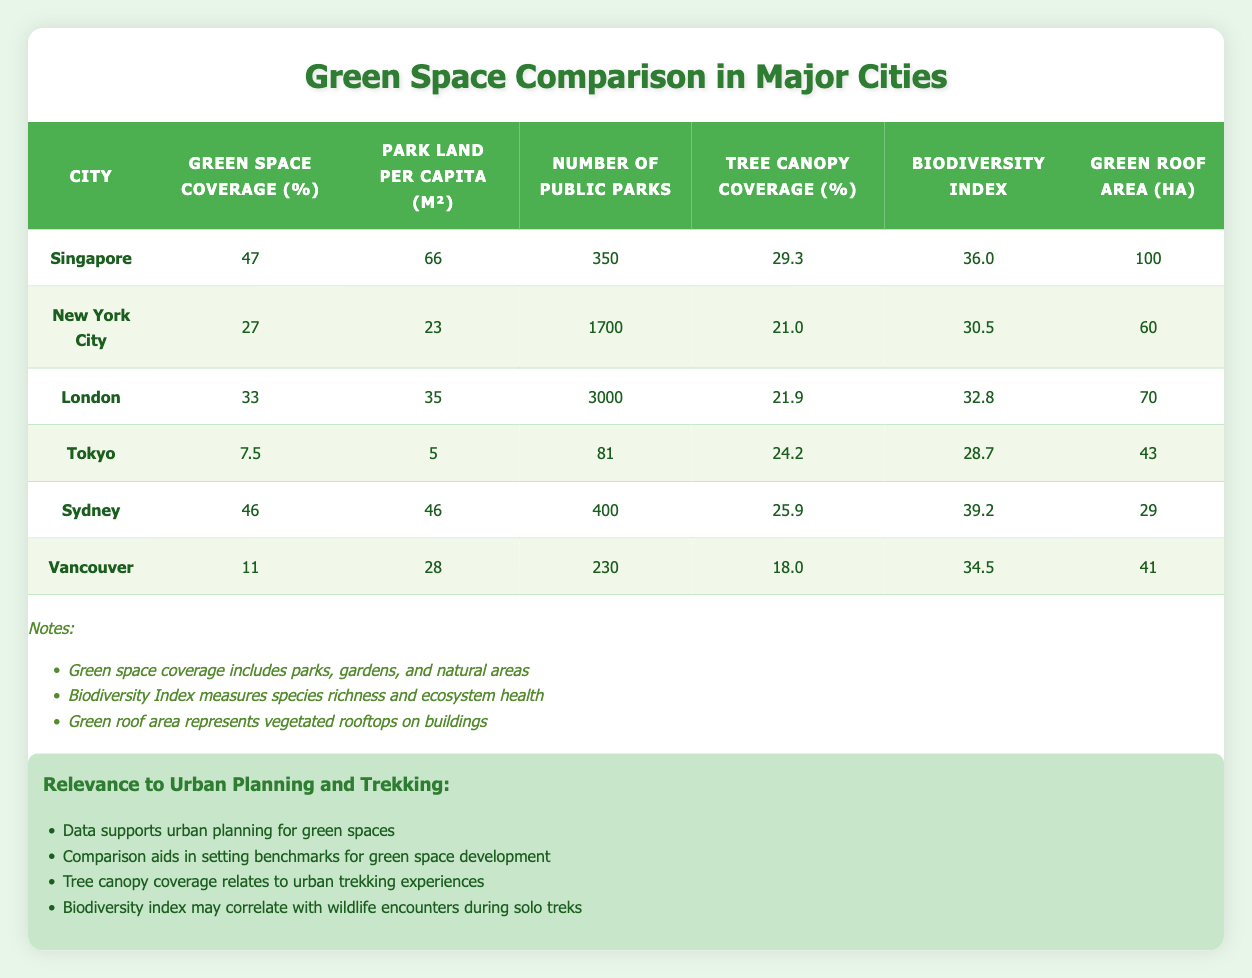What city has the highest green space coverage? By examining the "Green Space Coverage (%)" column, we see that Singapore has the highest value of 47%.
Answer: Singapore Which city has the most public parks? The "Number of Public Parks" column indicates that London has the highest count with 3000 public parks.
Answer: London What is the average park land per capita for the cities listed? To find the average, we sum the park land per capita values (66 + 23 + 35 + 5 + 46 + 28 = 203) and divide by the number of cities (203/6 = 33.83).
Answer: 33.83 m² Is the tree canopy coverage in Tokyo higher than that of New York City? Looking at the "Tree Canopy Coverage (%)" column, Tokyo has 24.2% while New York City has only 21.0%, so yes, Tokyo's coverage is higher.
Answer: Yes Which city has the lowest biodiversity index? The "Biodiversity Index" column shows that Tokyo has the lowest score of 28.7, indicating the least biodiversity among the cities.
Answer: Tokyo How much more green space coverage does Singapore have compared to Tokyo? We subtract Tokyo's green space coverage of 7.5% from Singapore's 47% (47 - 7.5 = 39.5), so Singapore has 39.5% more green space coverage.
Answer: 39.5% Is the tree canopy coverage in Sydney greater than the biodiversity index for New York City? Sydney has a tree canopy coverage of 25.9% while New York City has a biodiversity index of 30.5. Since 25.9% is not greater than 30.5, the answer is no.
Answer: No What is the total green roof area of all cities combined? Adding the green roof areas (100 + 60 + 70 + 43 + 29 + 41 = 443) gives us a total of 443 hectares across all cities.
Answer: 443 ha If we consider only cities with green space coverage greater than 30%, how many public parks are there in total? The cities with greater than 30% coverage are Singapore, London, and Sydney. Their public parks count (350 + 3000 + 400 = 3750) totals 3750 public parks.
Answer: 3750 